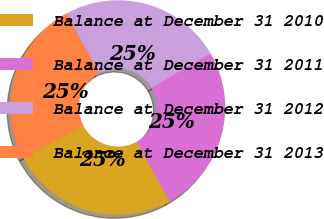Convert chart to OTSL. <chart><loc_0><loc_0><loc_500><loc_500><pie_chart><fcel>Balance at December 31 2010<fcel>Balance at December 31 2011<fcel>Balance at December 31 2012<fcel>Balance at December 31 2013<nl><fcel>25.3%<fcel>25.42%<fcel>24.59%<fcel>24.69%<nl></chart> 